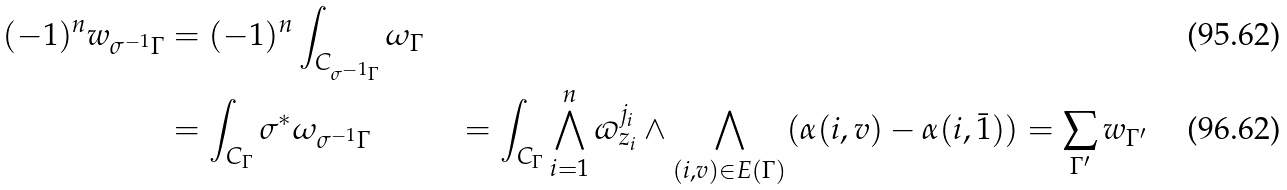Convert formula to latex. <formula><loc_0><loc_0><loc_500><loc_500>( - 1 ) ^ { n } w _ { \sigma ^ { - 1 } \Gamma } & = ( - 1 ) ^ { n } \int _ { C _ { \sigma ^ { - 1 } \Gamma } } \omega _ { \Gamma } \\ & = \int _ { C _ { \Gamma } } \sigma ^ { * } \omega _ { \sigma ^ { - 1 } \Gamma } & = \int _ { C _ { \Gamma } } \bigwedge _ { i = 1 } ^ { n } \varpi ^ { j _ { i } } _ { z _ { i } } \wedge \bigwedge _ { ( i , v ) \in E ( \Gamma ) } ( \alpha ( i , v ) - \alpha ( i , \bar { 1 } ) ) & = \sum _ { \Gamma ^ { \prime } } w _ { \Gamma ^ { \prime } }</formula> 